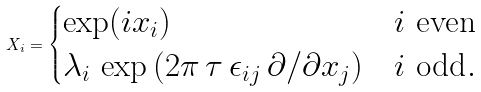<formula> <loc_0><loc_0><loc_500><loc_500>X _ { i } = \begin{cases} \exp ( i x _ { i } ) & i \ \text {even} \\ \lambda _ { i } \, \exp \left ( 2 \pi \, \tau \, \epsilon _ { i j } \, \partial / \partial x _ { j } \right ) & i \ \text {odd} . \end{cases}</formula> 